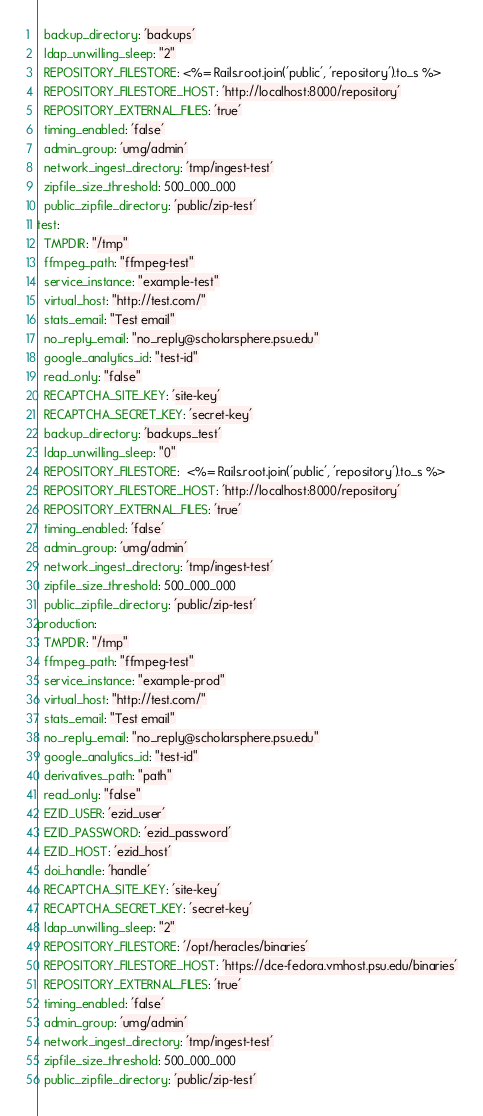Convert code to text. <code><loc_0><loc_0><loc_500><loc_500><_YAML_>  backup_directory: 'backups'
  ldap_unwilling_sleep: "2"
  REPOSITORY_FILESTORE: <%= Rails.root.join('public', 'repository').to_s %>
  REPOSITORY_FILESTORE_HOST: 'http://localhost:8000/repository'
  REPOSITORY_EXTERNAL_FILES: 'true'
  timing_enabled: 'false'
  admin_group: 'umg/admin'
  network_ingest_directory: 'tmp/ingest-test'
  zipfile_size_threshold: 500_000_000
  public_zipfile_directory: 'public/zip-test'
test:
  TMPDIR: "/tmp"
  ffmpeg_path: "ffmpeg-test"
  service_instance: "example-test"
  virtual_host: "http://test.com/"
  stats_email: "Test email"
  no_reply_email: "no_reply@scholarsphere.psu.edu"
  google_analytics_id: "test-id"
  read_only: "false"
  RECAPTCHA_SITE_KEY: 'site-key'
  RECAPTCHA_SECRET_KEY: 'secret-key'
  backup_directory: 'backups_test'
  ldap_unwilling_sleep: "0"
  REPOSITORY_FILESTORE:  <%= Rails.root.join('public', 'repository').to_s %>
  REPOSITORY_FILESTORE_HOST: 'http://localhost:8000/repository'
  REPOSITORY_EXTERNAL_FILES: 'true'
  timing_enabled: 'false'
  admin_group: 'umg/admin'
  network_ingest_directory: 'tmp/ingest-test'
  zipfile_size_threshold: 500_000_000
  public_zipfile_directory: 'public/zip-test'
production:
  TMPDIR: "/tmp"
  ffmpeg_path: "ffmpeg-test"
  service_instance: "example-prod"
  virtual_host: "http://test.com/"
  stats_email: "Test email"
  no_reply_email: "no_reply@scholarsphere.psu.edu"
  google_analytics_id: "test-id"
  derivatives_path: "path"
  read_only: "false"
  EZID_USER: 'ezid_user'
  EZID_PASSWORD: 'ezid_password'
  EZID_HOST: 'ezid_host'
  doi_handle: 'handle'
  RECAPTCHA_SITE_KEY: 'site-key'
  RECAPTCHA_SECRET_KEY: 'secret-key'
  ldap_unwilling_sleep: "2"
  REPOSITORY_FILESTORE: '/opt/heracles/binaries'
  REPOSITORY_FILESTORE_HOST: 'https://dce-fedora.vmhost.psu.edu/binaries'
  REPOSITORY_EXTERNAL_FILES: 'true'
  timing_enabled: 'false'
  admin_group: 'umg/admin'
  network_ingest_directory: 'tmp/ingest-test'
  zipfile_size_threshold: 500_000_000
  public_zipfile_directory: 'public/zip-test'
</code> 